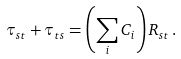<formula> <loc_0><loc_0><loc_500><loc_500>\tau _ { s t } + \tau _ { t s } = \left ( \sum _ { i } C _ { i } \right ) R _ { s t } \, .</formula> 